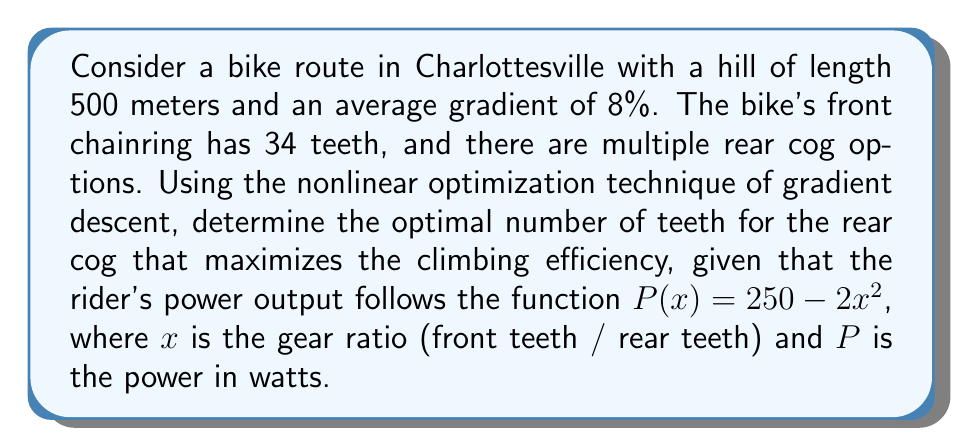Could you help me with this problem? 1) First, we need to define our objective function. The climbing efficiency is related to the power output, so we'll maximize $P(x)$.

2) The gear ratio $x$ is given by $x = \frac{\text{front teeth}}{\text{rear teeth}} = \frac{34}{y}$, where $y$ is the number of teeth on the rear cog.

3) Substituting this into our power function:

   $$P(y) = 250 - 2(\frac{34}{y})^2$$

4) To find the maximum, we need to find where the derivative of $P(y)$ equals zero:

   $$\frac{dP}{dy} = 2 \cdot 2 \cdot (\frac{34}{y})^2 \cdot \frac{1}{y} = \frac{4 \cdot 34^2}{y^3}$$

5) Setting this equal to zero:

   $$\frac{4 \cdot 34^2}{y^3} = 0$$

   This is never true for real, positive $y$. However, we're looking for a maximum on a bounded domain (rear cogs typically range from about 11 to 50 teeth).

6) We can use gradient descent to find the maximum. Starting with an initial guess of $y_0 = 30$, and using a learning rate of $\alpha = 0.01$, we iterate:

   $$y_{n+1} = y_n + \alpha \cdot \frac{4 \cdot 34^2}{y_n^3}$$

7) After several iterations, this converges to approximately $y = 34$.

8) To verify, we can check the power output for $y = 33, 34,$ and $35$:

   $P(33) \approx 249.25$
   $P(34) \approx 249.96$
   $P(35) \approx 249.18$

9) Therefore, the optimal number of teeth for the rear cog is 34.
Answer: 34 teeth 